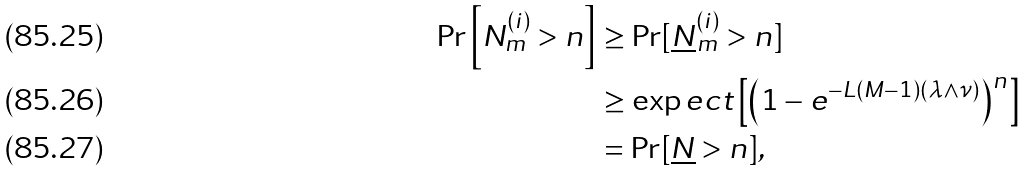<formula> <loc_0><loc_0><loc_500><loc_500>\Pr \left [ N _ { m } ^ { ( i ) } > n \right ] & \geq \Pr [ \underline { N } ^ { ( i ) } _ { m } > n ] \\ & \geq \exp e c t \left [ \left ( 1 - e ^ { - L ( M - 1 ) ( \lambda \wedge \nu ) } \right ) ^ { n } \right ] \\ & = \Pr [ \underline { N } > n ] ,</formula> 